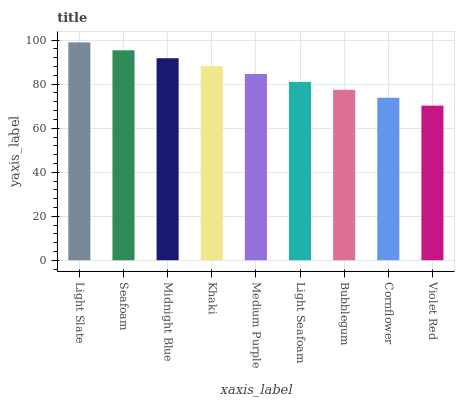Is Violet Red the minimum?
Answer yes or no. Yes. Is Light Slate the maximum?
Answer yes or no. Yes. Is Seafoam the minimum?
Answer yes or no. No. Is Seafoam the maximum?
Answer yes or no. No. Is Light Slate greater than Seafoam?
Answer yes or no. Yes. Is Seafoam less than Light Slate?
Answer yes or no. Yes. Is Seafoam greater than Light Slate?
Answer yes or no. No. Is Light Slate less than Seafoam?
Answer yes or no. No. Is Medium Purple the high median?
Answer yes or no. Yes. Is Medium Purple the low median?
Answer yes or no. Yes. Is Khaki the high median?
Answer yes or no. No. Is Violet Red the low median?
Answer yes or no. No. 